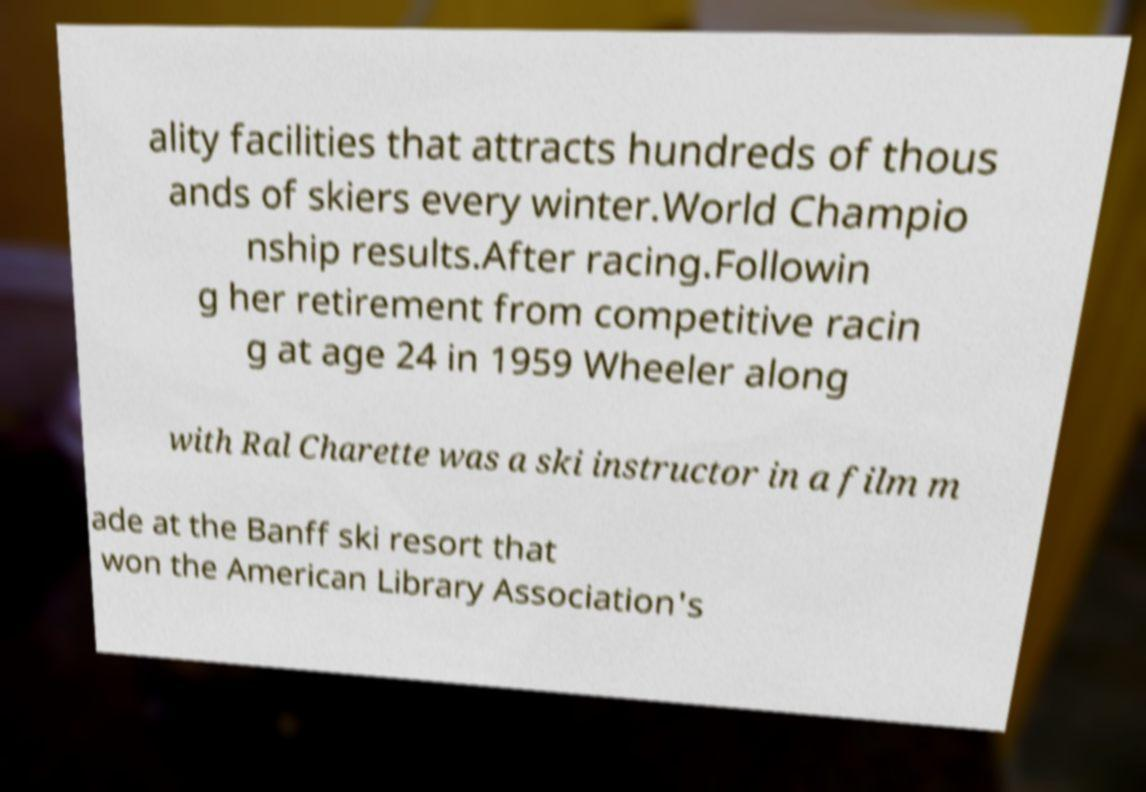There's text embedded in this image that I need extracted. Can you transcribe it verbatim? ality facilities that attracts hundreds of thous ands of skiers every winter.World Champio nship results.After racing.Followin g her retirement from competitive racin g at age 24 in 1959 Wheeler along with Ral Charette was a ski instructor in a film m ade at the Banff ski resort that won the American Library Association's 